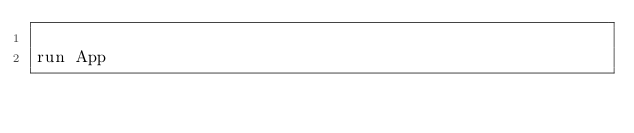<code> <loc_0><loc_0><loc_500><loc_500><_Ruby_>
run App
</code> 